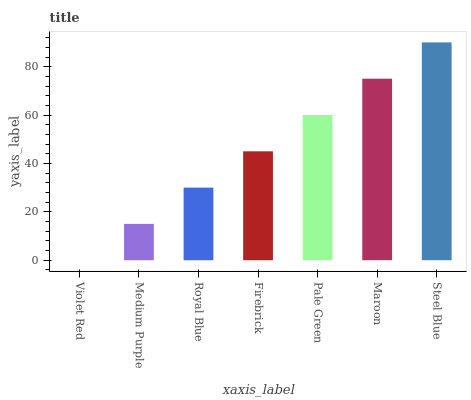Is Violet Red the minimum?
Answer yes or no. Yes. Is Steel Blue the maximum?
Answer yes or no. Yes. Is Medium Purple the minimum?
Answer yes or no. No. Is Medium Purple the maximum?
Answer yes or no. No. Is Medium Purple greater than Violet Red?
Answer yes or no. Yes. Is Violet Red less than Medium Purple?
Answer yes or no. Yes. Is Violet Red greater than Medium Purple?
Answer yes or no. No. Is Medium Purple less than Violet Red?
Answer yes or no. No. Is Firebrick the high median?
Answer yes or no. Yes. Is Firebrick the low median?
Answer yes or no. Yes. Is Violet Red the high median?
Answer yes or no. No. Is Medium Purple the low median?
Answer yes or no. No. 